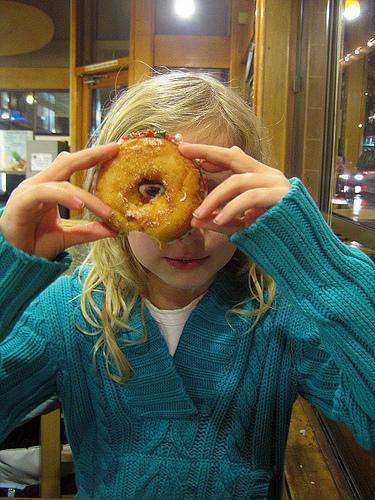Is this girl using a doughnut as a corrective lens?
Quick response, please. Yes. Is there sprinkles on the doughnut?
Be succinct. Yes. Is the girl wearing a sweater with long sleeves?
Keep it brief. Yes. 